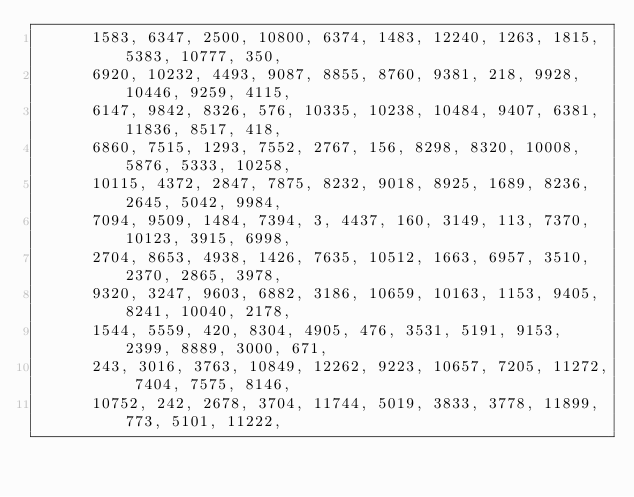Convert code to text. <code><loc_0><loc_0><loc_500><loc_500><_C++_>      1583, 6347, 2500, 10800, 6374, 1483, 12240, 1263, 1815, 5383, 10777, 350,
      6920, 10232, 4493, 9087, 8855, 8760, 9381, 218, 9928, 10446, 9259, 4115,
      6147, 9842, 8326, 576, 10335, 10238, 10484, 9407, 6381, 11836, 8517, 418,
      6860, 7515, 1293, 7552, 2767, 156, 8298, 8320, 10008, 5876, 5333, 10258,
      10115, 4372, 2847, 7875, 8232, 9018, 8925, 1689, 8236, 2645, 5042, 9984,
      7094, 9509, 1484, 7394, 3, 4437, 160, 3149, 113, 7370, 10123, 3915, 6998,
      2704, 8653, 4938, 1426, 7635, 10512, 1663, 6957, 3510, 2370, 2865, 3978,
      9320, 3247, 9603, 6882, 3186, 10659, 10163, 1153, 9405, 8241, 10040, 2178,
      1544, 5559, 420, 8304, 4905, 476, 3531, 5191, 9153, 2399, 8889, 3000, 671,
      243, 3016, 3763, 10849, 12262, 9223, 10657, 7205, 11272, 7404, 7575, 8146,
      10752, 242, 2678, 3704, 11744, 5019, 3833, 3778, 11899, 773, 5101, 11222,</code> 